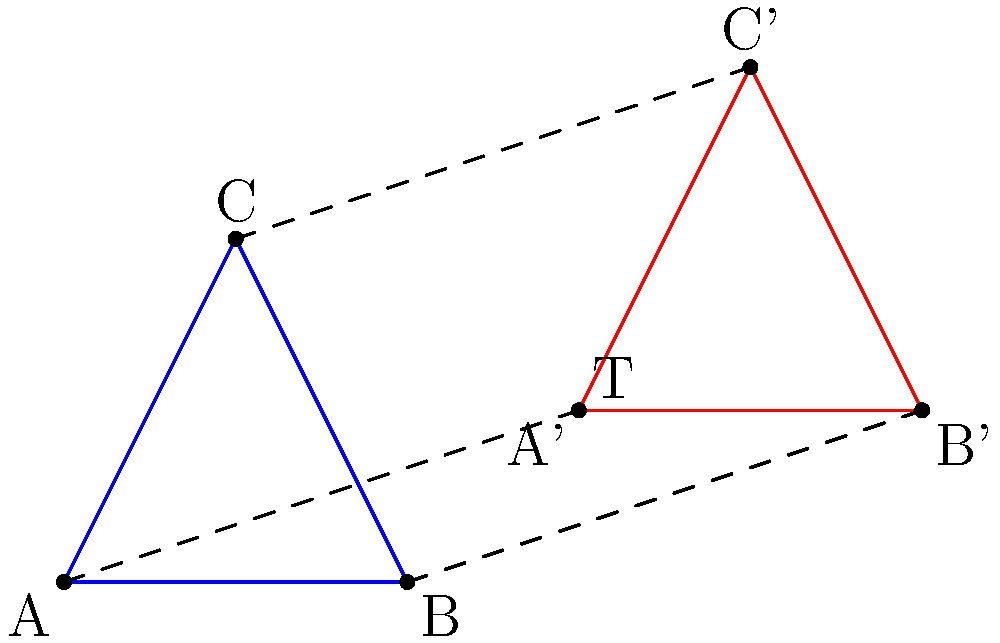In the context of memory address manipulation in Python, how does the translation of a triangle ABC by vector T relate to pointer arithmetic? Explain the analogy and potential security implications. To understand the analogy between geometric translation and memory address manipulation:

1. Geometric Translation:
   - Triangle ABC is translated by vector T(3,1)
   - Each point (A, B, C) moves by the same vector T
   - New coordinates: A' = A + T, B' = B + T, C' = C + T

2. Memory Address Manipulation:
   - In Python, memory addresses are abstracted, but the concept is similar to C-style pointer arithmetic
   - Consider an array in memory where each element occupies 4 bytes
   - The base address of the array is like point A
   - Moving to the next element is like adding a translation vector (4,0) in memory space

3. Analogy:
   - Geometric translation: A' = A + T
   - Pointer arithmetic: new_address = base_address + offset

4. Security Implications:
   - Buffer Overflow: Improper translation (offset calculation) can lead to accessing memory outside the intended bounds
   - Information Leakage: Translating to unintended memory locations may expose sensitive data
   - Code Injection: Malicious translation could overwrite return addresses or function pointers

5. Python-specific Considerations:
   - Python uses reference counting and garbage collection, which mitigates some low-level memory issues
   - However, when using ctypes or working with C extensions, similar risks apply
   - Bound checking in Python helps prevent many issues, but understanding the underlying concept is crucial for security reviews

6. Best Practices:
   - Use Python's built-in data structures and avoid manual memory management when possible
   - When working with C extensions, ensure proper bounds checking and input validation
   - Regularly update and patch dependencies to mitigate known vulnerabilities related to memory manipulation
Answer: Geometric translation analogous to pointer arithmetic; security risks include buffer overflows, information leakage, and potential code injection when improperly implemented, especially in C extensions. 